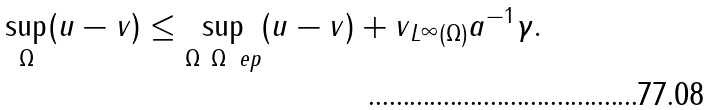<formula> <loc_0><loc_0><loc_500><loc_500>\sup _ { \Omega } ( u - v ) \leq \sup _ { \Omega \ \Omega _ { \ } e p } ( u - v ) + \| v \| _ { L ^ { \infty } ( \Omega ) } a ^ { - 1 } \gamma .</formula> 